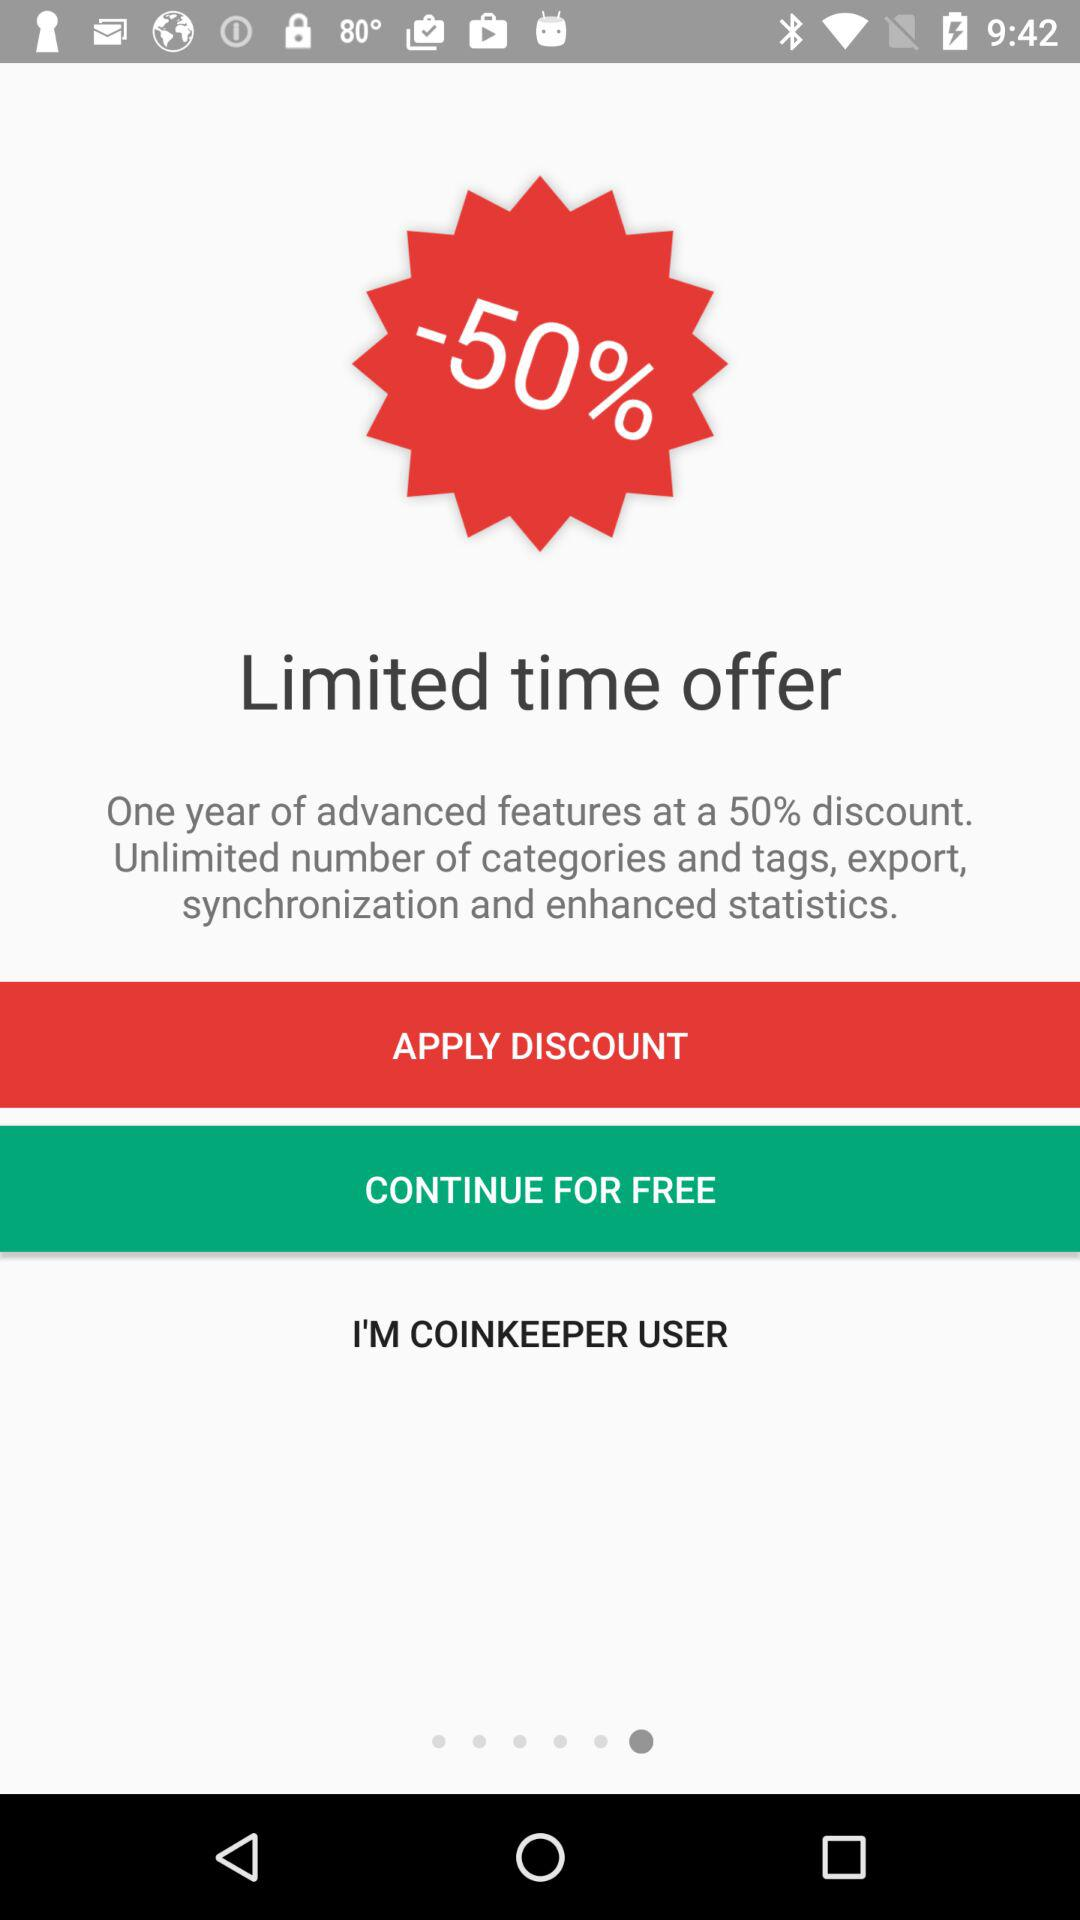Which features are considered advanced?
When the provided information is insufficient, respond with <no answer>. <no answer> 